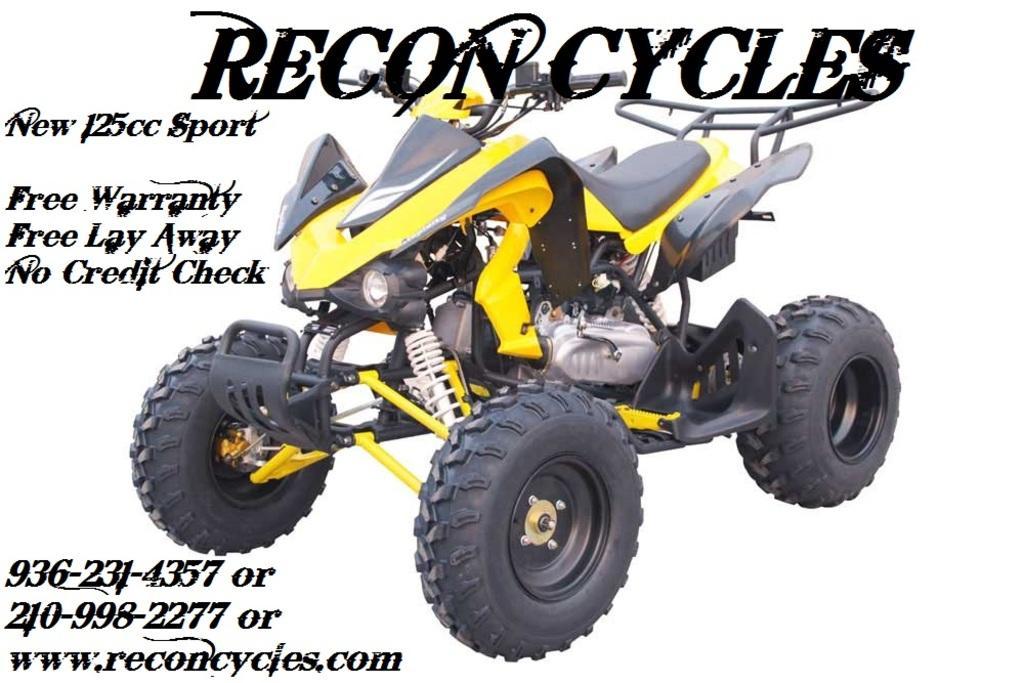In one or two sentences, can you explain what this image depicts? There is a poster having the image of a vehicle and there are texts on it. And the background of this vehicle is white in color. 